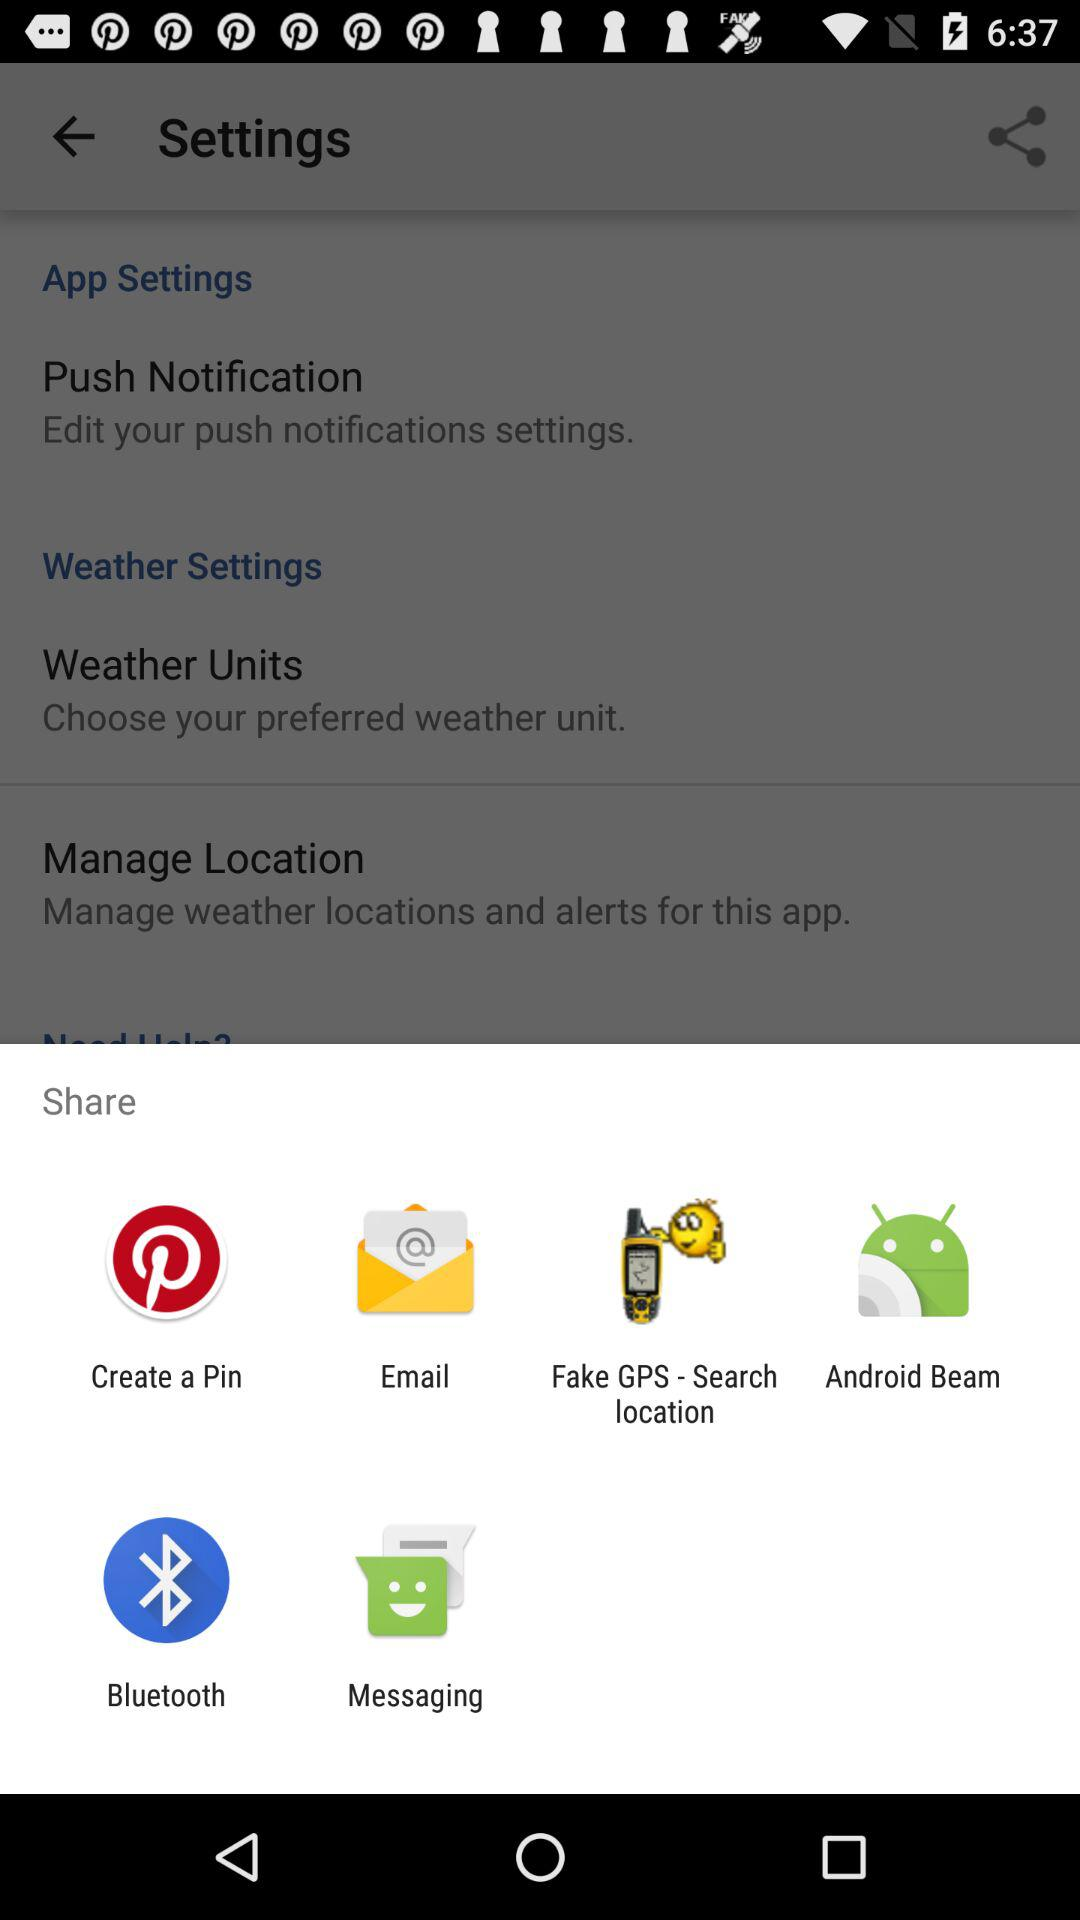Through which applications content can be shared? The content can be shared through "Create a Pin", "Email", "Fake GPS - Search location", "Android Beam", "Bluetooth" and "Messaging". 